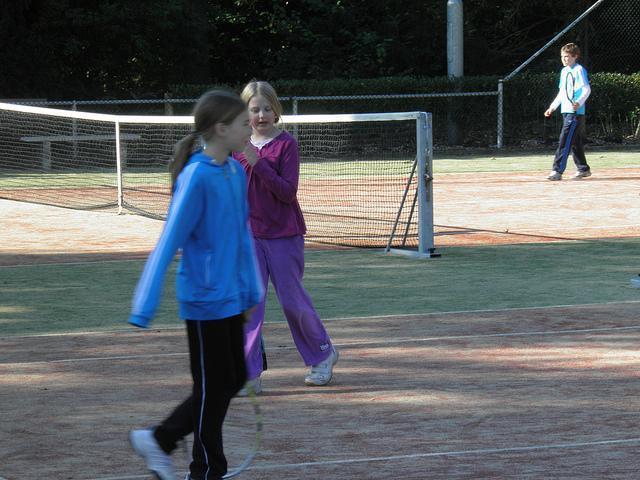How many people can you see?
Give a very brief answer. 3. 